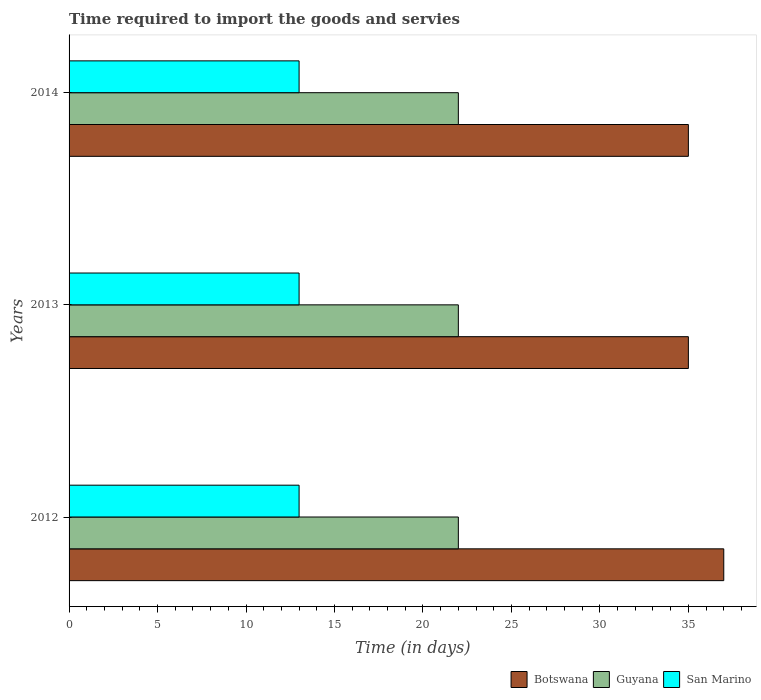How many different coloured bars are there?
Ensure brevity in your answer.  3. Are the number of bars per tick equal to the number of legend labels?
Ensure brevity in your answer.  Yes. Are the number of bars on each tick of the Y-axis equal?
Give a very brief answer. Yes. How many bars are there on the 1st tick from the top?
Provide a short and direct response. 3. How many bars are there on the 1st tick from the bottom?
Provide a short and direct response. 3. In how many cases, is the number of bars for a given year not equal to the number of legend labels?
Your response must be concise. 0. What is the number of days required to import the goods and services in Guyana in 2012?
Offer a very short reply. 22. Across all years, what is the minimum number of days required to import the goods and services in Botswana?
Your response must be concise. 35. In which year was the number of days required to import the goods and services in Botswana minimum?
Make the answer very short. 2013. What is the total number of days required to import the goods and services in Botswana in the graph?
Provide a succinct answer. 107. In the year 2014, what is the difference between the number of days required to import the goods and services in Botswana and number of days required to import the goods and services in Guyana?
Your answer should be very brief. 13. In how many years, is the number of days required to import the goods and services in San Marino greater than 24 days?
Your answer should be compact. 0. What is the ratio of the number of days required to import the goods and services in Botswana in 2012 to that in 2013?
Your answer should be very brief. 1.06. What is the difference between the highest and the lowest number of days required to import the goods and services in Botswana?
Offer a terse response. 2. What does the 3rd bar from the top in 2012 represents?
Give a very brief answer. Botswana. What does the 2nd bar from the bottom in 2014 represents?
Offer a very short reply. Guyana. Is it the case that in every year, the sum of the number of days required to import the goods and services in Guyana and number of days required to import the goods and services in Botswana is greater than the number of days required to import the goods and services in San Marino?
Keep it short and to the point. Yes. How many bars are there?
Your answer should be compact. 9. What is the difference between two consecutive major ticks on the X-axis?
Ensure brevity in your answer.  5. Are the values on the major ticks of X-axis written in scientific E-notation?
Provide a short and direct response. No. Does the graph contain any zero values?
Your answer should be compact. No. How many legend labels are there?
Provide a succinct answer. 3. How are the legend labels stacked?
Your answer should be very brief. Horizontal. What is the title of the graph?
Offer a very short reply. Time required to import the goods and servies. Does "Papua New Guinea" appear as one of the legend labels in the graph?
Offer a very short reply. No. What is the label or title of the X-axis?
Make the answer very short. Time (in days). What is the Time (in days) of Guyana in 2012?
Keep it short and to the point. 22. What is the Time (in days) of Botswana in 2014?
Your answer should be very brief. 35. What is the Time (in days) of Guyana in 2014?
Ensure brevity in your answer.  22. What is the Time (in days) of San Marino in 2014?
Your response must be concise. 13. Across all years, what is the minimum Time (in days) in Guyana?
Provide a succinct answer. 22. What is the total Time (in days) of Botswana in the graph?
Offer a terse response. 107. What is the total Time (in days) of Guyana in the graph?
Make the answer very short. 66. What is the total Time (in days) of San Marino in the graph?
Provide a short and direct response. 39. What is the difference between the Time (in days) in Botswana in 2012 and that in 2013?
Keep it short and to the point. 2. What is the difference between the Time (in days) in Botswana in 2012 and that in 2014?
Give a very brief answer. 2. What is the difference between the Time (in days) in Guyana in 2012 and that in 2014?
Provide a succinct answer. 0. What is the difference between the Time (in days) in Guyana in 2013 and that in 2014?
Give a very brief answer. 0. What is the difference between the Time (in days) in San Marino in 2013 and that in 2014?
Provide a short and direct response. 0. What is the difference between the Time (in days) of Botswana in 2012 and the Time (in days) of Guyana in 2013?
Give a very brief answer. 15. What is the difference between the Time (in days) in Botswana in 2012 and the Time (in days) in San Marino in 2013?
Your answer should be very brief. 24. What is the difference between the Time (in days) in Guyana in 2012 and the Time (in days) in San Marino in 2013?
Give a very brief answer. 9. What is the difference between the Time (in days) in Botswana in 2012 and the Time (in days) in Guyana in 2014?
Make the answer very short. 15. What is the difference between the Time (in days) of Guyana in 2012 and the Time (in days) of San Marino in 2014?
Your answer should be compact. 9. What is the difference between the Time (in days) of Botswana in 2013 and the Time (in days) of San Marino in 2014?
Give a very brief answer. 22. What is the difference between the Time (in days) in Guyana in 2013 and the Time (in days) in San Marino in 2014?
Provide a short and direct response. 9. What is the average Time (in days) in Botswana per year?
Your answer should be very brief. 35.67. What is the average Time (in days) in Guyana per year?
Your response must be concise. 22. In the year 2012, what is the difference between the Time (in days) of Botswana and Time (in days) of Guyana?
Provide a succinct answer. 15. In the year 2012, what is the difference between the Time (in days) of Guyana and Time (in days) of San Marino?
Give a very brief answer. 9. In the year 2013, what is the difference between the Time (in days) in Botswana and Time (in days) in Guyana?
Ensure brevity in your answer.  13. In the year 2013, what is the difference between the Time (in days) of Guyana and Time (in days) of San Marino?
Provide a short and direct response. 9. What is the ratio of the Time (in days) of Botswana in 2012 to that in 2013?
Provide a short and direct response. 1.06. What is the ratio of the Time (in days) of Guyana in 2012 to that in 2013?
Make the answer very short. 1. What is the ratio of the Time (in days) in San Marino in 2012 to that in 2013?
Offer a very short reply. 1. What is the ratio of the Time (in days) in Botswana in 2012 to that in 2014?
Offer a terse response. 1.06. What is the ratio of the Time (in days) of Guyana in 2012 to that in 2014?
Give a very brief answer. 1. What is the ratio of the Time (in days) of San Marino in 2012 to that in 2014?
Offer a terse response. 1. What is the ratio of the Time (in days) of Botswana in 2013 to that in 2014?
Your response must be concise. 1. What is the ratio of the Time (in days) of Guyana in 2013 to that in 2014?
Keep it short and to the point. 1. What is the ratio of the Time (in days) in San Marino in 2013 to that in 2014?
Offer a very short reply. 1. What is the difference between the highest and the second highest Time (in days) in Guyana?
Offer a terse response. 0. What is the difference between the highest and the lowest Time (in days) in Botswana?
Your answer should be very brief. 2. 